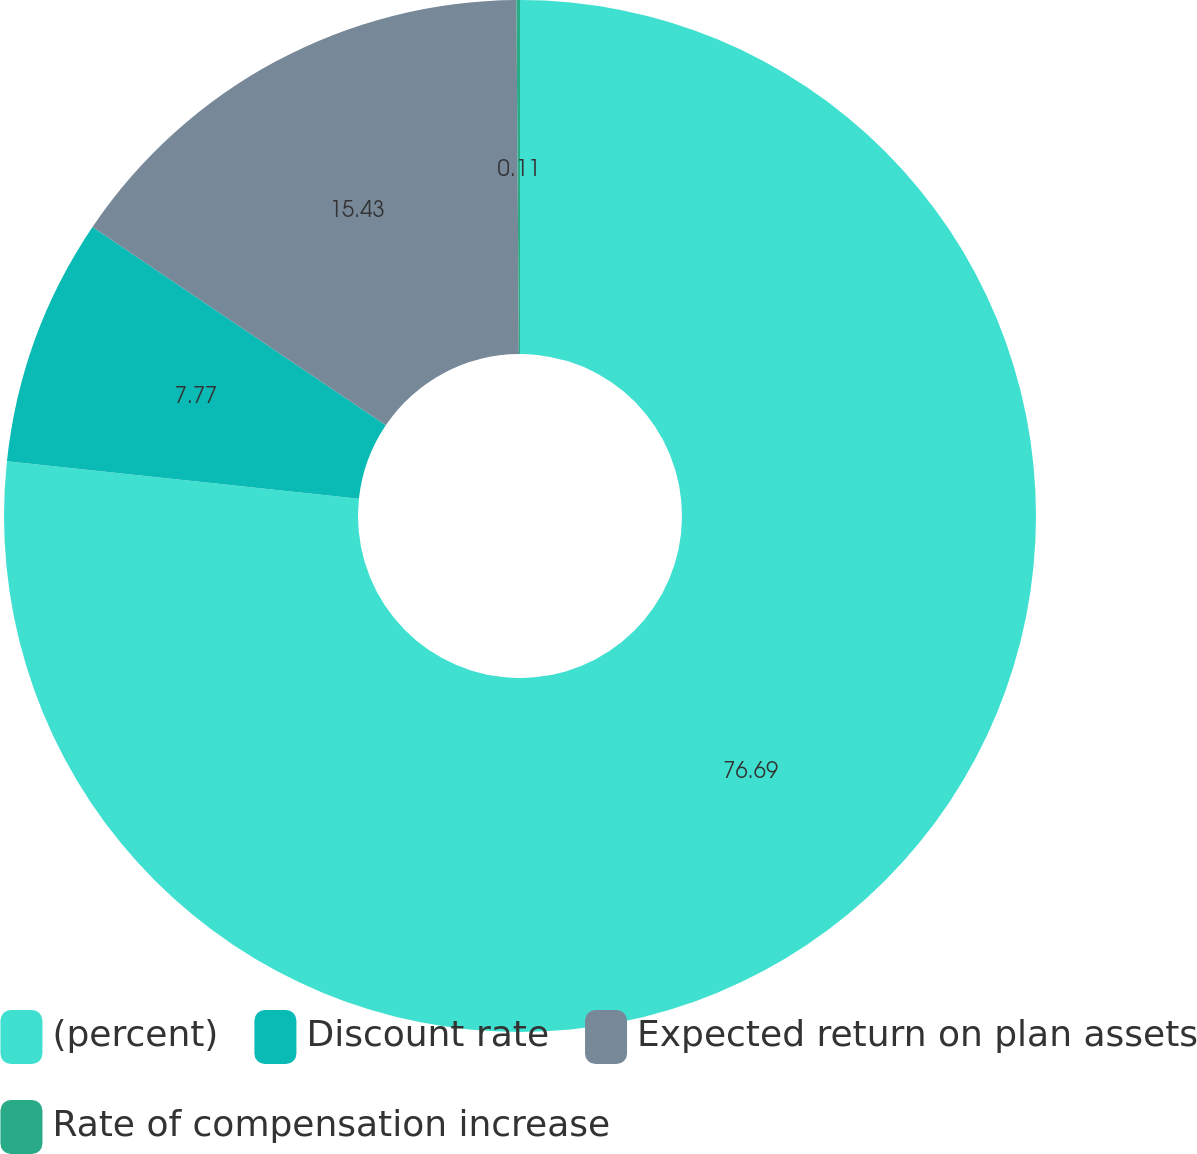Convert chart to OTSL. <chart><loc_0><loc_0><loc_500><loc_500><pie_chart><fcel>(percent)<fcel>Discount rate<fcel>Expected return on plan assets<fcel>Rate of compensation increase<nl><fcel>76.7%<fcel>7.77%<fcel>15.43%<fcel>0.11%<nl></chart> 